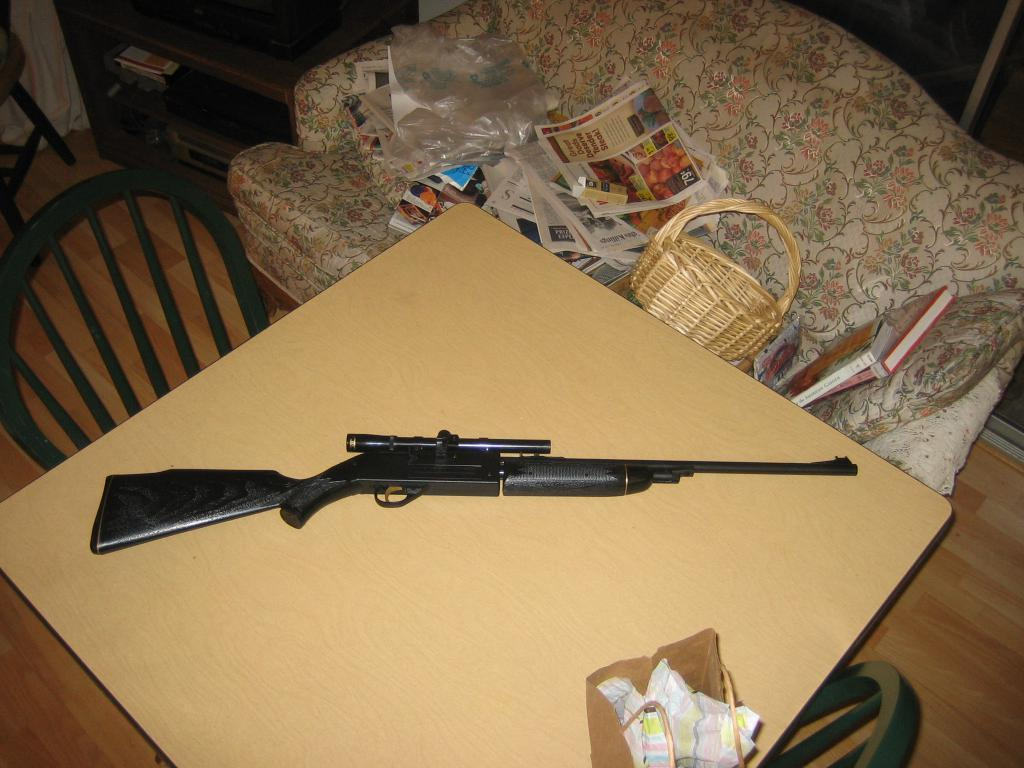What object is placed on the table in the image? There is a gun on the table. What furniture can be seen in the background of the image? There are two chairs in the background. What items are present in the background of the image? There are papers and a basket in the background. Where is the book located in the image? The book is on a couch. How does the cart help in maintaining the quiet atmosphere in the image? There is no cart present in the image, so it cannot contribute to maintaining a quiet atmosphere. 